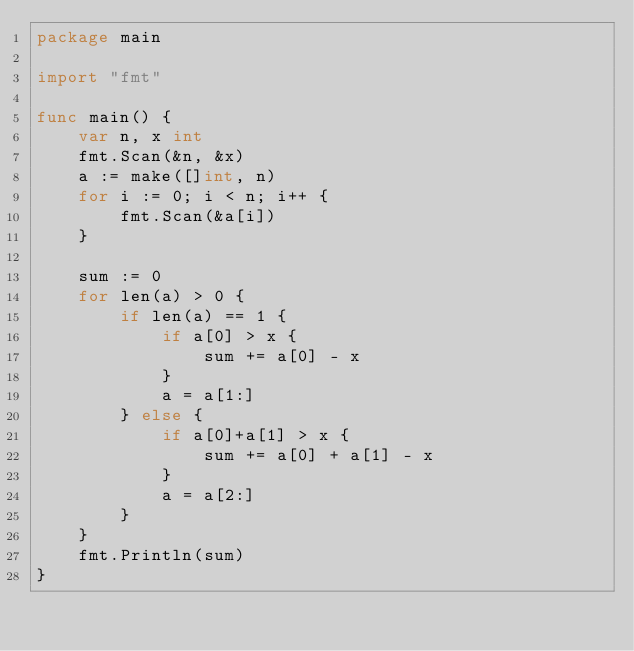<code> <loc_0><loc_0><loc_500><loc_500><_Go_>package main

import "fmt"

func main() {
	var n, x int
	fmt.Scan(&n, &x)
	a := make([]int, n)
	for i := 0; i < n; i++ {
		fmt.Scan(&a[i])
	}

	sum := 0
	for len(a) > 0 {
		if len(a) == 1 {
			if a[0] > x {
				sum += a[0] - x
			}
			a = a[1:]
		} else {
			if a[0]+a[1] > x {
				sum += a[0] + a[1] - x
			}
			a = a[2:]
		}
	}
	fmt.Println(sum)
}
</code> 